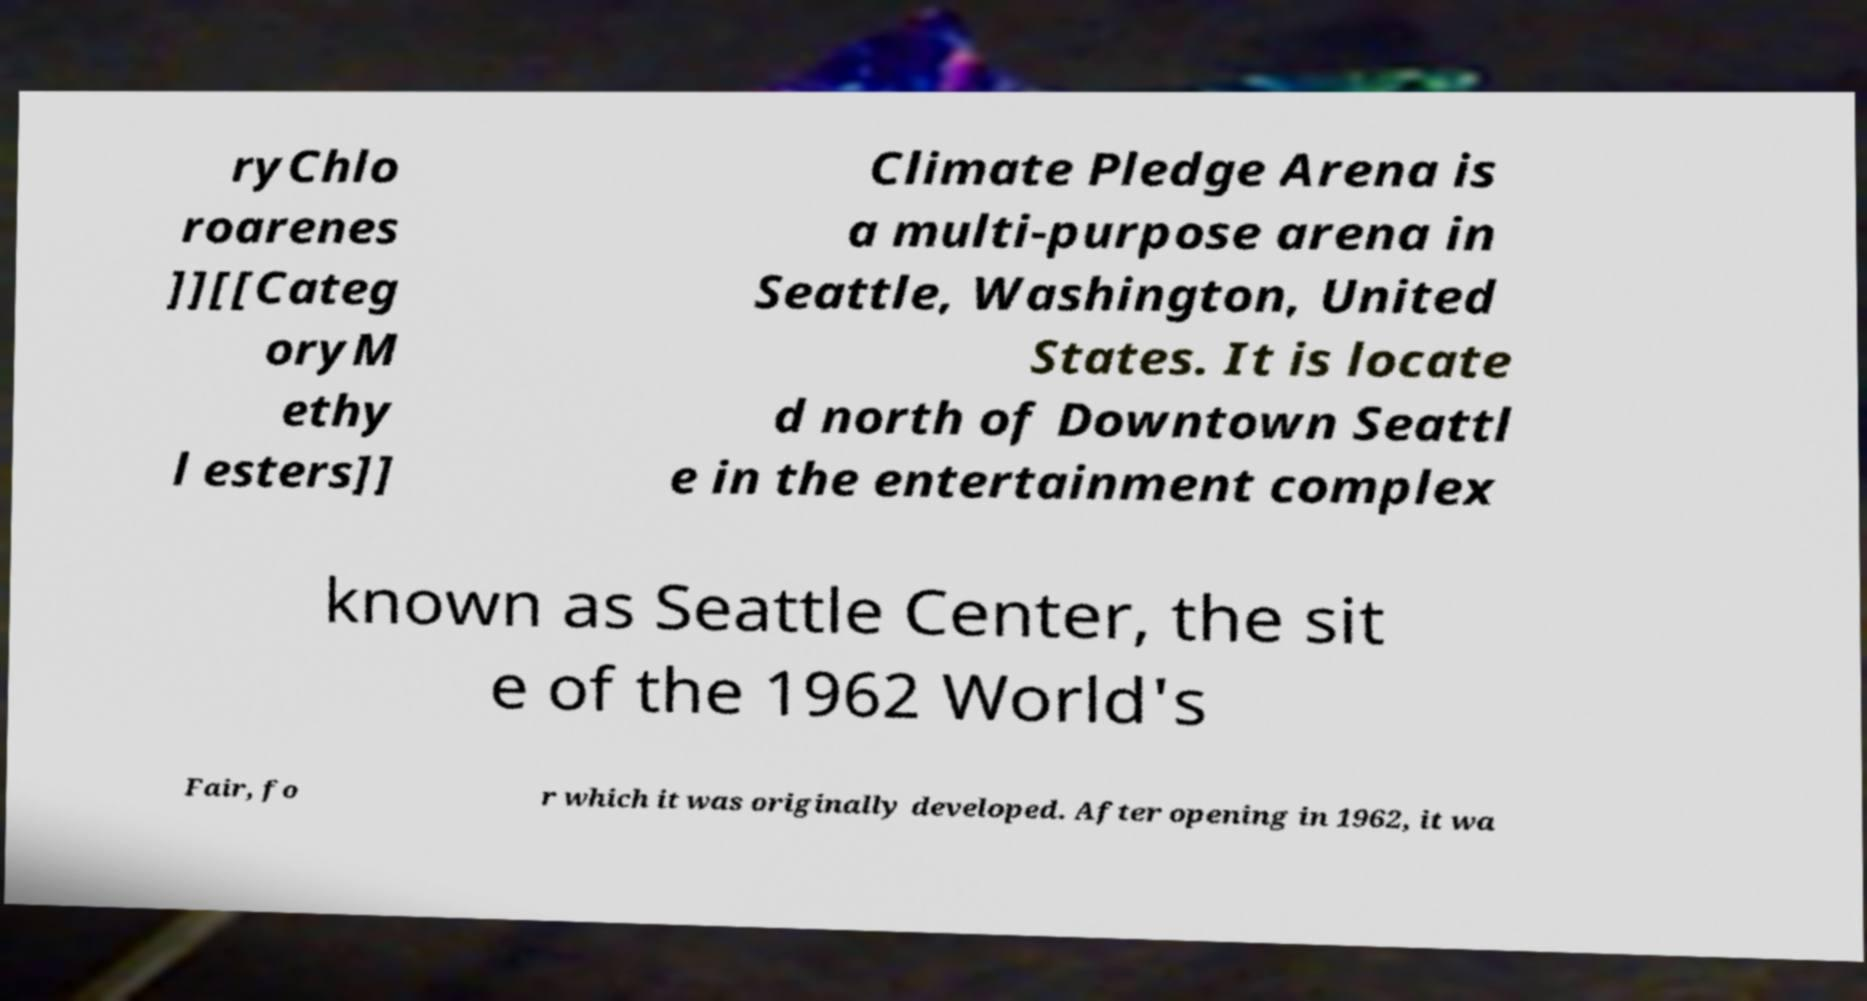Could you extract and type out the text from this image? ryChlo roarenes ]][[Categ oryM ethy l esters]] Climate Pledge Arena is a multi-purpose arena in Seattle, Washington, United States. It is locate d north of Downtown Seattl e in the entertainment complex known as Seattle Center, the sit e of the 1962 World's Fair, fo r which it was originally developed. After opening in 1962, it wa 